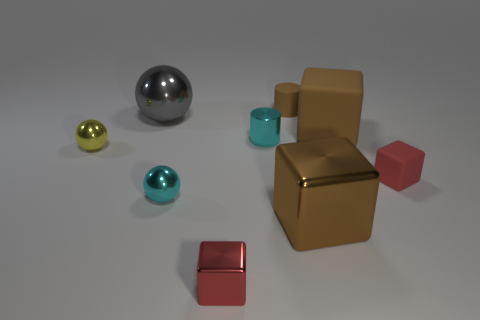Add 1 large cubes. How many objects exist? 10 Subtract all brown shiny blocks. How many blocks are left? 3 Subtract 1 cylinders. How many cylinders are left? 1 Subtract all brown balls. How many brown blocks are left? 2 Subtract all cyan spheres. How many spheres are left? 2 Subtract all blocks. How many objects are left? 5 Add 1 gray metal things. How many gray metal things are left? 2 Add 6 small cyan rubber cubes. How many small cyan rubber cubes exist? 6 Subtract 1 cyan spheres. How many objects are left? 8 Subtract all purple blocks. Subtract all brown balls. How many blocks are left? 4 